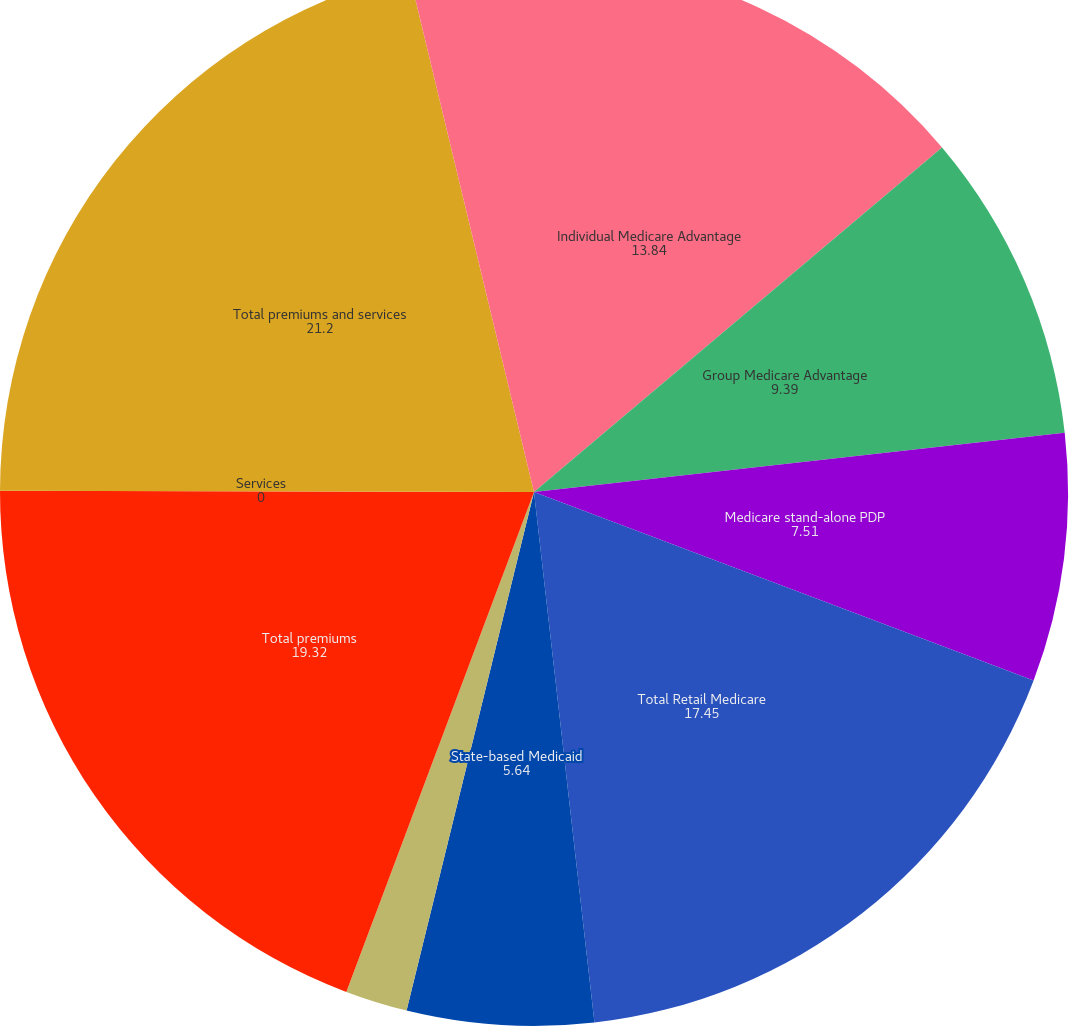Convert chart. <chart><loc_0><loc_0><loc_500><loc_500><pie_chart><fcel>Individual Medicare Advantage<fcel>Group Medicare Advantage<fcel>Medicare stand-alone PDP<fcel>Total Retail Medicare<fcel>State-based Medicaid<fcel>Medicare Supplement<fcel>Total premiums<fcel>Services<fcel>Total premiums and services<fcel>Income before income taxes<nl><fcel>13.84%<fcel>9.39%<fcel>7.51%<fcel>17.45%<fcel>5.64%<fcel>1.88%<fcel>19.32%<fcel>0.0%<fcel>21.2%<fcel>3.76%<nl></chart> 